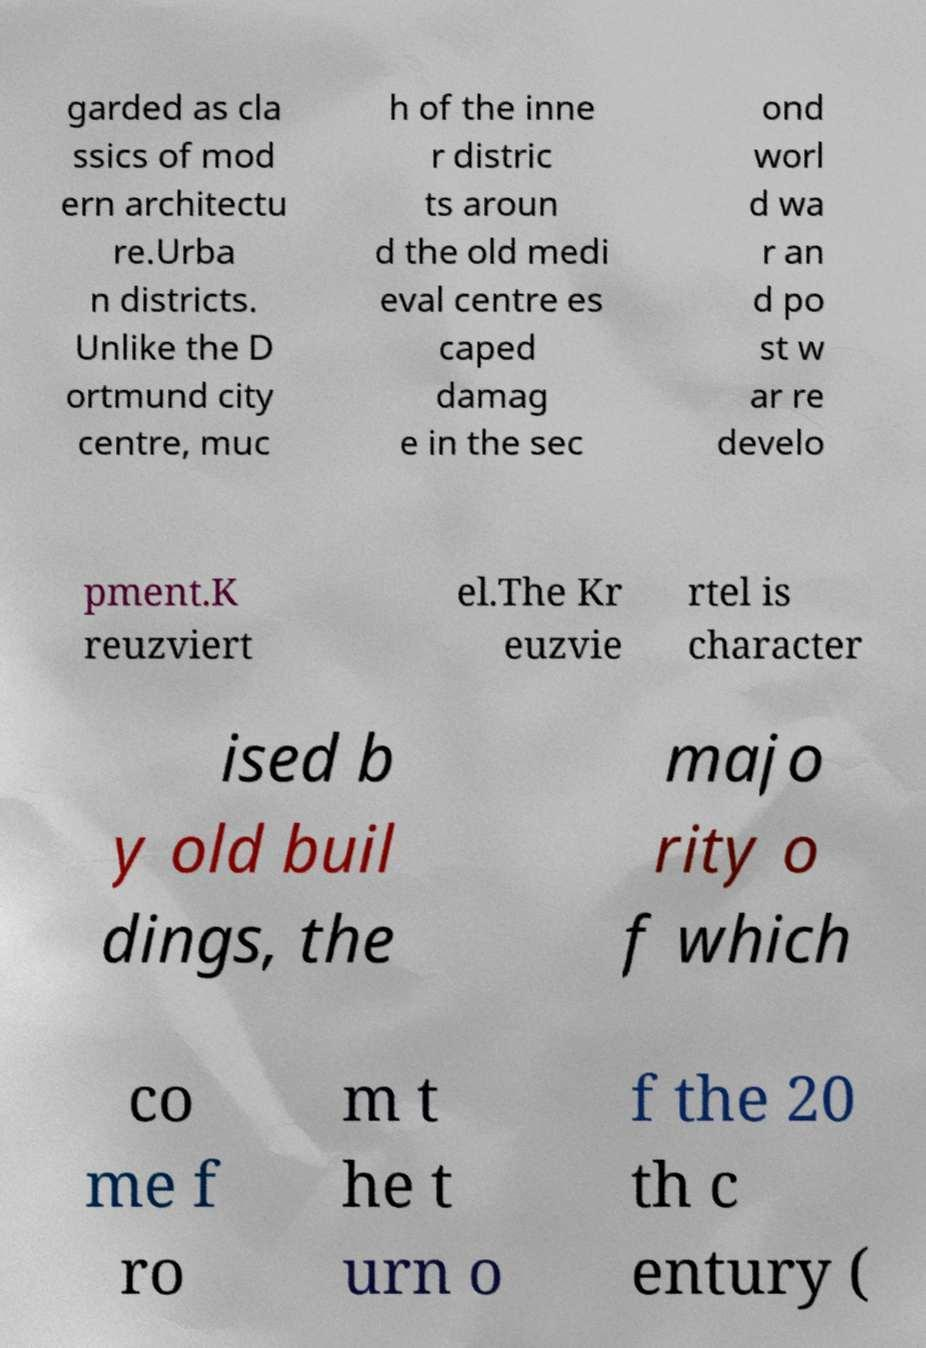Can you read and provide the text displayed in the image?This photo seems to have some interesting text. Can you extract and type it out for me? garded as cla ssics of mod ern architectu re.Urba n districts. Unlike the D ortmund city centre, muc h of the inne r distric ts aroun d the old medi eval centre es caped damag e in the sec ond worl d wa r an d po st w ar re develo pment.K reuzviert el.The Kr euzvie rtel is character ised b y old buil dings, the majo rity o f which co me f ro m t he t urn o f the 20 th c entury ( 